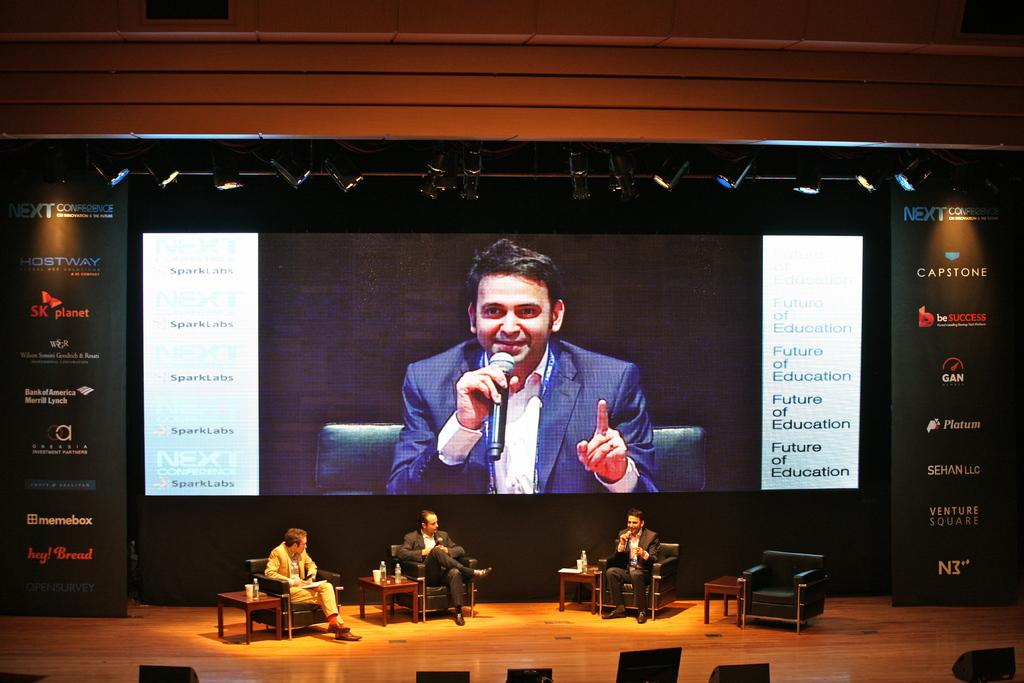<image>
Summarize the visual content of the image. A man is shown on a large screen at a conference sponsored by Capstone and many other companies. 